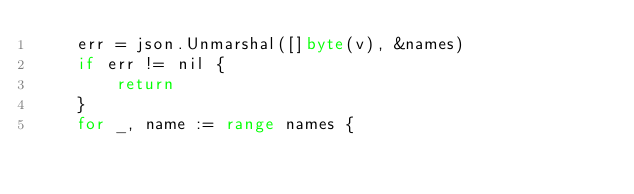Convert code to text. <code><loc_0><loc_0><loc_500><loc_500><_Go_>	err = json.Unmarshal([]byte(v), &names)
	if err != nil {
		return
	}
	for _, name := range names {</code> 